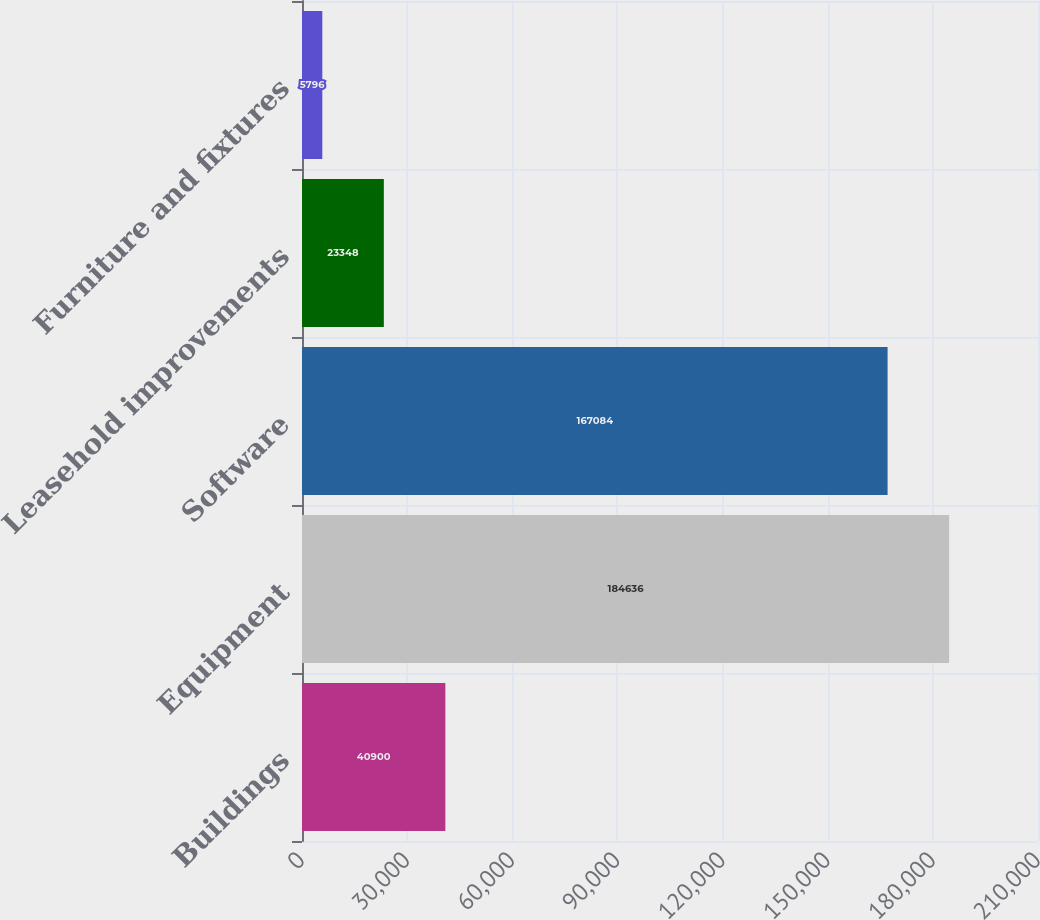<chart> <loc_0><loc_0><loc_500><loc_500><bar_chart><fcel>Buildings<fcel>Equipment<fcel>Software<fcel>Leasehold improvements<fcel>Furniture and fixtures<nl><fcel>40900<fcel>184636<fcel>167084<fcel>23348<fcel>5796<nl></chart> 